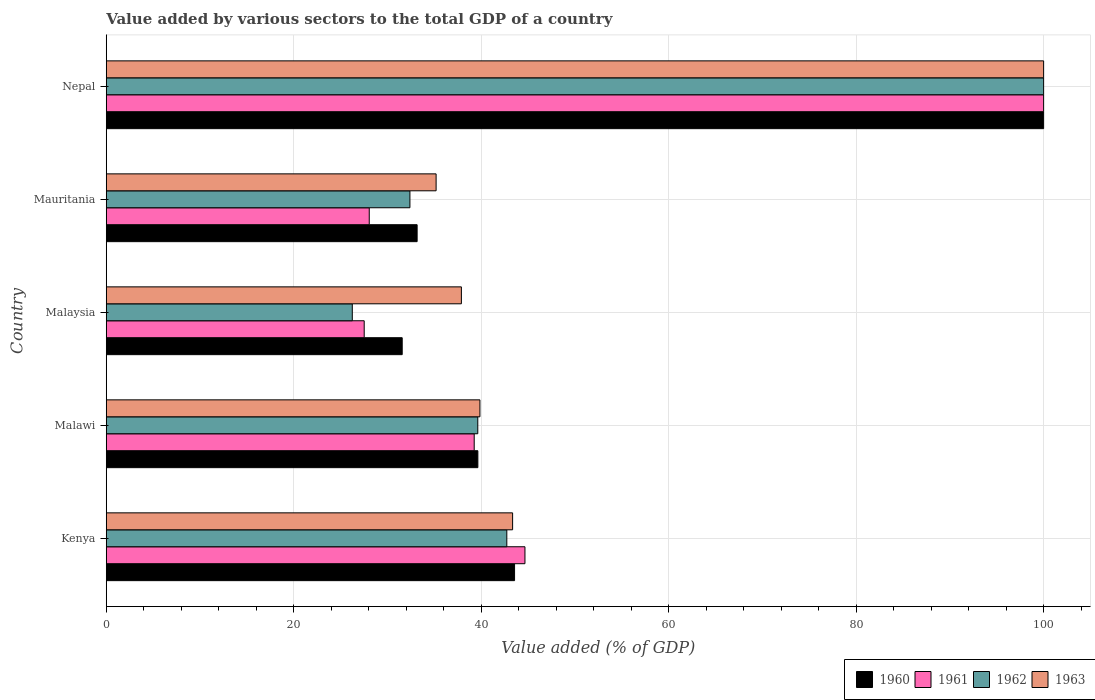How many different coloured bars are there?
Make the answer very short. 4. Are the number of bars per tick equal to the number of legend labels?
Keep it short and to the point. Yes. What is the label of the 2nd group of bars from the top?
Provide a short and direct response. Mauritania. What is the value added by various sectors to the total GDP in 1962 in Malawi?
Keep it short and to the point. 39.64. Across all countries, what is the maximum value added by various sectors to the total GDP in 1960?
Give a very brief answer. 100. Across all countries, what is the minimum value added by various sectors to the total GDP in 1961?
Ensure brevity in your answer.  27.52. In which country was the value added by various sectors to the total GDP in 1962 maximum?
Offer a terse response. Nepal. In which country was the value added by various sectors to the total GDP in 1963 minimum?
Offer a very short reply. Mauritania. What is the total value added by various sectors to the total GDP in 1961 in the graph?
Ensure brevity in your answer.  239.5. What is the difference between the value added by various sectors to the total GDP in 1961 in Kenya and that in Malawi?
Offer a very short reply. 5.41. What is the difference between the value added by various sectors to the total GDP in 1961 in Mauritania and the value added by various sectors to the total GDP in 1960 in Nepal?
Your answer should be compact. -71.94. What is the average value added by various sectors to the total GDP in 1960 per country?
Offer a terse response. 49.59. What is the difference between the value added by various sectors to the total GDP in 1963 and value added by various sectors to the total GDP in 1960 in Mauritania?
Give a very brief answer. 2.02. What is the ratio of the value added by various sectors to the total GDP in 1963 in Kenya to that in Nepal?
Ensure brevity in your answer.  0.43. Is the value added by various sectors to the total GDP in 1963 in Kenya less than that in Nepal?
Your answer should be very brief. Yes. What is the difference between the highest and the second highest value added by various sectors to the total GDP in 1962?
Keep it short and to the point. 57.27. What is the difference between the highest and the lowest value added by various sectors to the total GDP in 1963?
Ensure brevity in your answer.  64.81. In how many countries, is the value added by various sectors to the total GDP in 1961 greater than the average value added by various sectors to the total GDP in 1961 taken over all countries?
Offer a very short reply. 1. Is the sum of the value added by various sectors to the total GDP in 1961 in Malawi and Mauritania greater than the maximum value added by various sectors to the total GDP in 1960 across all countries?
Offer a terse response. No. How many bars are there?
Ensure brevity in your answer.  20. Are all the bars in the graph horizontal?
Ensure brevity in your answer.  Yes. Are the values on the major ticks of X-axis written in scientific E-notation?
Provide a succinct answer. No. Does the graph contain grids?
Provide a short and direct response. Yes. How many legend labels are there?
Make the answer very short. 4. What is the title of the graph?
Your answer should be compact. Value added by various sectors to the total GDP of a country. What is the label or title of the X-axis?
Keep it short and to the point. Value added (% of GDP). What is the label or title of the Y-axis?
Provide a short and direct response. Country. What is the Value added (% of GDP) in 1960 in Kenya?
Keep it short and to the point. 43.56. What is the Value added (% of GDP) in 1961 in Kenya?
Offer a very short reply. 44.67. What is the Value added (% of GDP) in 1962 in Kenya?
Give a very brief answer. 42.73. What is the Value added (% of GDP) in 1963 in Kenya?
Keep it short and to the point. 43.35. What is the Value added (% of GDP) in 1960 in Malawi?
Give a very brief answer. 39.64. What is the Value added (% of GDP) of 1961 in Malawi?
Offer a terse response. 39.25. What is the Value added (% of GDP) in 1962 in Malawi?
Offer a terse response. 39.64. What is the Value added (% of GDP) in 1963 in Malawi?
Give a very brief answer. 39.86. What is the Value added (% of GDP) of 1960 in Malaysia?
Offer a very short reply. 31.57. What is the Value added (% of GDP) in 1961 in Malaysia?
Your answer should be very brief. 27.52. What is the Value added (% of GDP) in 1962 in Malaysia?
Provide a short and direct response. 26.25. What is the Value added (% of GDP) in 1963 in Malaysia?
Your answer should be very brief. 37.89. What is the Value added (% of GDP) in 1960 in Mauritania?
Provide a short and direct response. 33.17. What is the Value added (% of GDP) in 1961 in Mauritania?
Provide a succinct answer. 28.06. What is the Value added (% of GDP) in 1962 in Mauritania?
Keep it short and to the point. 32.4. What is the Value added (% of GDP) in 1963 in Mauritania?
Provide a short and direct response. 35.19. What is the Value added (% of GDP) in 1962 in Nepal?
Offer a terse response. 100. What is the Value added (% of GDP) in 1963 in Nepal?
Your answer should be very brief. 100. Across all countries, what is the maximum Value added (% of GDP) in 1962?
Provide a succinct answer. 100. Across all countries, what is the maximum Value added (% of GDP) in 1963?
Make the answer very short. 100. Across all countries, what is the minimum Value added (% of GDP) in 1960?
Give a very brief answer. 31.57. Across all countries, what is the minimum Value added (% of GDP) of 1961?
Make the answer very short. 27.52. Across all countries, what is the minimum Value added (% of GDP) of 1962?
Offer a very short reply. 26.25. Across all countries, what is the minimum Value added (% of GDP) in 1963?
Keep it short and to the point. 35.19. What is the total Value added (% of GDP) in 1960 in the graph?
Keep it short and to the point. 247.94. What is the total Value added (% of GDP) of 1961 in the graph?
Make the answer very short. 239.5. What is the total Value added (% of GDP) of 1962 in the graph?
Offer a very short reply. 241.01. What is the total Value added (% of GDP) in 1963 in the graph?
Your answer should be compact. 256.29. What is the difference between the Value added (% of GDP) of 1960 in Kenya and that in Malawi?
Your answer should be compact. 3.92. What is the difference between the Value added (% of GDP) in 1961 in Kenya and that in Malawi?
Keep it short and to the point. 5.41. What is the difference between the Value added (% of GDP) of 1962 in Kenya and that in Malawi?
Your response must be concise. 3.1. What is the difference between the Value added (% of GDP) of 1963 in Kenya and that in Malawi?
Your answer should be compact. 3.49. What is the difference between the Value added (% of GDP) of 1960 in Kenya and that in Malaysia?
Provide a short and direct response. 11.99. What is the difference between the Value added (% of GDP) of 1961 in Kenya and that in Malaysia?
Provide a succinct answer. 17.15. What is the difference between the Value added (% of GDP) of 1962 in Kenya and that in Malaysia?
Your answer should be very brief. 16.48. What is the difference between the Value added (% of GDP) of 1963 in Kenya and that in Malaysia?
Offer a very short reply. 5.46. What is the difference between the Value added (% of GDP) of 1960 in Kenya and that in Mauritania?
Keep it short and to the point. 10.39. What is the difference between the Value added (% of GDP) in 1961 in Kenya and that in Mauritania?
Your response must be concise. 16.61. What is the difference between the Value added (% of GDP) of 1962 in Kenya and that in Mauritania?
Provide a succinct answer. 10.34. What is the difference between the Value added (% of GDP) in 1963 in Kenya and that in Mauritania?
Offer a terse response. 8.16. What is the difference between the Value added (% of GDP) of 1960 in Kenya and that in Nepal?
Offer a very short reply. -56.44. What is the difference between the Value added (% of GDP) of 1961 in Kenya and that in Nepal?
Ensure brevity in your answer.  -55.33. What is the difference between the Value added (% of GDP) in 1962 in Kenya and that in Nepal?
Your response must be concise. -57.27. What is the difference between the Value added (% of GDP) of 1963 in Kenya and that in Nepal?
Offer a terse response. -56.65. What is the difference between the Value added (% of GDP) in 1960 in Malawi and that in Malaysia?
Give a very brief answer. 8.07. What is the difference between the Value added (% of GDP) of 1961 in Malawi and that in Malaysia?
Give a very brief answer. 11.73. What is the difference between the Value added (% of GDP) of 1962 in Malawi and that in Malaysia?
Provide a short and direct response. 13.39. What is the difference between the Value added (% of GDP) in 1963 in Malawi and that in Malaysia?
Your answer should be compact. 1.98. What is the difference between the Value added (% of GDP) of 1960 in Malawi and that in Mauritania?
Provide a succinct answer. 6.48. What is the difference between the Value added (% of GDP) in 1961 in Malawi and that in Mauritania?
Provide a short and direct response. 11.2. What is the difference between the Value added (% of GDP) of 1962 in Malawi and that in Mauritania?
Offer a very short reply. 7.24. What is the difference between the Value added (% of GDP) of 1963 in Malawi and that in Mauritania?
Your answer should be compact. 4.67. What is the difference between the Value added (% of GDP) of 1960 in Malawi and that in Nepal?
Provide a short and direct response. -60.36. What is the difference between the Value added (% of GDP) in 1961 in Malawi and that in Nepal?
Provide a succinct answer. -60.75. What is the difference between the Value added (% of GDP) of 1962 in Malawi and that in Nepal?
Make the answer very short. -60.36. What is the difference between the Value added (% of GDP) of 1963 in Malawi and that in Nepal?
Offer a very short reply. -60.14. What is the difference between the Value added (% of GDP) of 1960 in Malaysia and that in Mauritania?
Your answer should be compact. -1.59. What is the difference between the Value added (% of GDP) of 1961 in Malaysia and that in Mauritania?
Your response must be concise. -0.54. What is the difference between the Value added (% of GDP) in 1962 in Malaysia and that in Mauritania?
Provide a short and direct response. -6.15. What is the difference between the Value added (% of GDP) of 1963 in Malaysia and that in Mauritania?
Provide a short and direct response. 2.7. What is the difference between the Value added (% of GDP) in 1960 in Malaysia and that in Nepal?
Give a very brief answer. -68.43. What is the difference between the Value added (% of GDP) of 1961 in Malaysia and that in Nepal?
Make the answer very short. -72.48. What is the difference between the Value added (% of GDP) of 1962 in Malaysia and that in Nepal?
Your answer should be compact. -73.75. What is the difference between the Value added (% of GDP) of 1963 in Malaysia and that in Nepal?
Provide a succinct answer. -62.11. What is the difference between the Value added (% of GDP) of 1960 in Mauritania and that in Nepal?
Give a very brief answer. -66.83. What is the difference between the Value added (% of GDP) of 1961 in Mauritania and that in Nepal?
Provide a short and direct response. -71.94. What is the difference between the Value added (% of GDP) in 1962 in Mauritania and that in Nepal?
Your answer should be very brief. -67.6. What is the difference between the Value added (% of GDP) of 1963 in Mauritania and that in Nepal?
Make the answer very short. -64.81. What is the difference between the Value added (% of GDP) in 1960 in Kenya and the Value added (% of GDP) in 1961 in Malawi?
Keep it short and to the point. 4.31. What is the difference between the Value added (% of GDP) of 1960 in Kenya and the Value added (% of GDP) of 1962 in Malawi?
Give a very brief answer. 3.92. What is the difference between the Value added (% of GDP) of 1960 in Kenya and the Value added (% of GDP) of 1963 in Malawi?
Your answer should be very brief. 3.7. What is the difference between the Value added (% of GDP) of 1961 in Kenya and the Value added (% of GDP) of 1962 in Malawi?
Give a very brief answer. 5.03. What is the difference between the Value added (% of GDP) of 1961 in Kenya and the Value added (% of GDP) of 1963 in Malawi?
Ensure brevity in your answer.  4.8. What is the difference between the Value added (% of GDP) in 1962 in Kenya and the Value added (% of GDP) in 1963 in Malawi?
Your response must be concise. 2.87. What is the difference between the Value added (% of GDP) in 1960 in Kenya and the Value added (% of GDP) in 1961 in Malaysia?
Your answer should be compact. 16.04. What is the difference between the Value added (% of GDP) of 1960 in Kenya and the Value added (% of GDP) of 1962 in Malaysia?
Offer a very short reply. 17.31. What is the difference between the Value added (% of GDP) in 1960 in Kenya and the Value added (% of GDP) in 1963 in Malaysia?
Provide a short and direct response. 5.67. What is the difference between the Value added (% of GDP) of 1961 in Kenya and the Value added (% of GDP) of 1962 in Malaysia?
Give a very brief answer. 18.42. What is the difference between the Value added (% of GDP) in 1961 in Kenya and the Value added (% of GDP) in 1963 in Malaysia?
Your answer should be compact. 6.78. What is the difference between the Value added (% of GDP) of 1962 in Kenya and the Value added (% of GDP) of 1963 in Malaysia?
Provide a short and direct response. 4.84. What is the difference between the Value added (% of GDP) in 1960 in Kenya and the Value added (% of GDP) in 1961 in Mauritania?
Offer a very short reply. 15.5. What is the difference between the Value added (% of GDP) of 1960 in Kenya and the Value added (% of GDP) of 1962 in Mauritania?
Offer a terse response. 11.16. What is the difference between the Value added (% of GDP) in 1960 in Kenya and the Value added (% of GDP) in 1963 in Mauritania?
Your response must be concise. 8.37. What is the difference between the Value added (% of GDP) in 1961 in Kenya and the Value added (% of GDP) in 1962 in Mauritania?
Your answer should be compact. 12.27. What is the difference between the Value added (% of GDP) in 1961 in Kenya and the Value added (% of GDP) in 1963 in Mauritania?
Provide a short and direct response. 9.48. What is the difference between the Value added (% of GDP) in 1962 in Kenya and the Value added (% of GDP) in 1963 in Mauritania?
Your answer should be very brief. 7.54. What is the difference between the Value added (% of GDP) of 1960 in Kenya and the Value added (% of GDP) of 1961 in Nepal?
Ensure brevity in your answer.  -56.44. What is the difference between the Value added (% of GDP) of 1960 in Kenya and the Value added (% of GDP) of 1962 in Nepal?
Provide a short and direct response. -56.44. What is the difference between the Value added (% of GDP) of 1960 in Kenya and the Value added (% of GDP) of 1963 in Nepal?
Your response must be concise. -56.44. What is the difference between the Value added (% of GDP) of 1961 in Kenya and the Value added (% of GDP) of 1962 in Nepal?
Your response must be concise. -55.33. What is the difference between the Value added (% of GDP) of 1961 in Kenya and the Value added (% of GDP) of 1963 in Nepal?
Offer a terse response. -55.33. What is the difference between the Value added (% of GDP) in 1962 in Kenya and the Value added (% of GDP) in 1963 in Nepal?
Your answer should be very brief. -57.27. What is the difference between the Value added (% of GDP) in 1960 in Malawi and the Value added (% of GDP) in 1961 in Malaysia?
Give a very brief answer. 12.13. What is the difference between the Value added (% of GDP) in 1960 in Malawi and the Value added (% of GDP) in 1962 in Malaysia?
Provide a succinct answer. 13.39. What is the difference between the Value added (% of GDP) of 1960 in Malawi and the Value added (% of GDP) of 1963 in Malaysia?
Keep it short and to the point. 1.76. What is the difference between the Value added (% of GDP) in 1961 in Malawi and the Value added (% of GDP) in 1962 in Malaysia?
Make the answer very short. 13. What is the difference between the Value added (% of GDP) in 1961 in Malawi and the Value added (% of GDP) in 1963 in Malaysia?
Keep it short and to the point. 1.37. What is the difference between the Value added (% of GDP) in 1962 in Malawi and the Value added (% of GDP) in 1963 in Malaysia?
Your response must be concise. 1.75. What is the difference between the Value added (% of GDP) in 1960 in Malawi and the Value added (% of GDP) in 1961 in Mauritania?
Make the answer very short. 11.59. What is the difference between the Value added (% of GDP) in 1960 in Malawi and the Value added (% of GDP) in 1962 in Mauritania?
Your answer should be very brief. 7.25. What is the difference between the Value added (% of GDP) of 1960 in Malawi and the Value added (% of GDP) of 1963 in Mauritania?
Your response must be concise. 4.45. What is the difference between the Value added (% of GDP) of 1961 in Malawi and the Value added (% of GDP) of 1962 in Mauritania?
Provide a short and direct response. 6.86. What is the difference between the Value added (% of GDP) of 1961 in Malawi and the Value added (% of GDP) of 1963 in Mauritania?
Make the answer very short. 4.06. What is the difference between the Value added (% of GDP) in 1962 in Malawi and the Value added (% of GDP) in 1963 in Mauritania?
Ensure brevity in your answer.  4.45. What is the difference between the Value added (% of GDP) in 1960 in Malawi and the Value added (% of GDP) in 1961 in Nepal?
Offer a very short reply. -60.36. What is the difference between the Value added (% of GDP) of 1960 in Malawi and the Value added (% of GDP) of 1962 in Nepal?
Provide a succinct answer. -60.36. What is the difference between the Value added (% of GDP) in 1960 in Malawi and the Value added (% of GDP) in 1963 in Nepal?
Provide a short and direct response. -60.36. What is the difference between the Value added (% of GDP) of 1961 in Malawi and the Value added (% of GDP) of 1962 in Nepal?
Make the answer very short. -60.75. What is the difference between the Value added (% of GDP) of 1961 in Malawi and the Value added (% of GDP) of 1963 in Nepal?
Your answer should be very brief. -60.75. What is the difference between the Value added (% of GDP) in 1962 in Malawi and the Value added (% of GDP) in 1963 in Nepal?
Offer a very short reply. -60.36. What is the difference between the Value added (% of GDP) of 1960 in Malaysia and the Value added (% of GDP) of 1961 in Mauritania?
Provide a short and direct response. 3.51. What is the difference between the Value added (% of GDP) of 1960 in Malaysia and the Value added (% of GDP) of 1962 in Mauritania?
Give a very brief answer. -0.82. What is the difference between the Value added (% of GDP) in 1960 in Malaysia and the Value added (% of GDP) in 1963 in Mauritania?
Your response must be concise. -3.62. What is the difference between the Value added (% of GDP) of 1961 in Malaysia and the Value added (% of GDP) of 1962 in Mauritania?
Your answer should be compact. -4.88. What is the difference between the Value added (% of GDP) of 1961 in Malaysia and the Value added (% of GDP) of 1963 in Mauritania?
Your answer should be compact. -7.67. What is the difference between the Value added (% of GDP) in 1962 in Malaysia and the Value added (% of GDP) in 1963 in Mauritania?
Give a very brief answer. -8.94. What is the difference between the Value added (% of GDP) of 1960 in Malaysia and the Value added (% of GDP) of 1961 in Nepal?
Your answer should be compact. -68.43. What is the difference between the Value added (% of GDP) of 1960 in Malaysia and the Value added (% of GDP) of 1962 in Nepal?
Give a very brief answer. -68.43. What is the difference between the Value added (% of GDP) of 1960 in Malaysia and the Value added (% of GDP) of 1963 in Nepal?
Offer a terse response. -68.43. What is the difference between the Value added (% of GDP) of 1961 in Malaysia and the Value added (% of GDP) of 1962 in Nepal?
Give a very brief answer. -72.48. What is the difference between the Value added (% of GDP) in 1961 in Malaysia and the Value added (% of GDP) in 1963 in Nepal?
Make the answer very short. -72.48. What is the difference between the Value added (% of GDP) of 1962 in Malaysia and the Value added (% of GDP) of 1963 in Nepal?
Give a very brief answer. -73.75. What is the difference between the Value added (% of GDP) of 1960 in Mauritania and the Value added (% of GDP) of 1961 in Nepal?
Provide a succinct answer. -66.83. What is the difference between the Value added (% of GDP) of 1960 in Mauritania and the Value added (% of GDP) of 1962 in Nepal?
Your answer should be compact. -66.83. What is the difference between the Value added (% of GDP) in 1960 in Mauritania and the Value added (% of GDP) in 1963 in Nepal?
Ensure brevity in your answer.  -66.83. What is the difference between the Value added (% of GDP) of 1961 in Mauritania and the Value added (% of GDP) of 1962 in Nepal?
Offer a terse response. -71.94. What is the difference between the Value added (% of GDP) of 1961 in Mauritania and the Value added (% of GDP) of 1963 in Nepal?
Keep it short and to the point. -71.94. What is the difference between the Value added (% of GDP) of 1962 in Mauritania and the Value added (% of GDP) of 1963 in Nepal?
Ensure brevity in your answer.  -67.6. What is the average Value added (% of GDP) of 1960 per country?
Make the answer very short. 49.59. What is the average Value added (% of GDP) in 1961 per country?
Keep it short and to the point. 47.9. What is the average Value added (% of GDP) in 1962 per country?
Your answer should be very brief. 48.2. What is the average Value added (% of GDP) in 1963 per country?
Provide a succinct answer. 51.26. What is the difference between the Value added (% of GDP) of 1960 and Value added (% of GDP) of 1961 in Kenya?
Offer a very short reply. -1.11. What is the difference between the Value added (% of GDP) of 1960 and Value added (% of GDP) of 1962 in Kenya?
Make the answer very short. 0.83. What is the difference between the Value added (% of GDP) of 1960 and Value added (% of GDP) of 1963 in Kenya?
Keep it short and to the point. 0.21. What is the difference between the Value added (% of GDP) in 1961 and Value added (% of GDP) in 1962 in Kenya?
Make the answer very short. 1.94. What is the difference between the Value added (% of GDP) in 1961 and Value added (% of GDP) in 1963 in Kenya?
Keep it short and to the point. 1.32. What is the difference between the Value added (% of GDP) in 1962 and Value added (% of GDP) in 1963 in Kenya?
Ensure brevity in your answer.  -0.62. What is the difference between the Value added (% of GDP) of 1960 and Value added (% of GDP) of 1961 in Malawi?
Keep it short and to the point. 0.39. What is the difference between the Value added (% of GDP) in 1960 and Value added (% of GDP) in 1962 in Malawi?
Make the answer very short. 0.01. What is the difference between the Value added (% of GDP) in 1960 and Value added (% of GDP) in 1963 in Malawi?
Provide a short and direct response. -0.22. What is the difference between the Value added (% of GDP) of 1961 and Value added (% of GDP) of 1962 in Malawi?
Your answer should be compact. -0.38. What is the difference between the Value added (% of GDP) in 1961 and Value added (% of GDP) in 1963 in Malawi?
Keep it short and to the point. -0.61. What is the difference between the Value added (% of GDP) of 1962 and Value added (% of GDP) of 1963 in Malawi?
Your answer should be compact. -0.23. What is the difference between the Value added (% of GDP) in 1960 and Value added (% of GDP) in 1961 in Malaysia?
Ensure brevity in your answer.  4.05. What is the difference between the Value added (% of GDP) in 1960 and Value added (% of GDP) in 1962 in Malaysia?
Your answer should be compact. 5.32. What is the difference between the Value added (% of GDP) in 1960 and Value added (% of GDP) in 1963 in Malaysia?
Offer a very short reply. -6.31. What is the difference between the Value added (% of GDP) of 1961 and Value added (% of GDP) of 1962 in Malaysia?
Your response must be concise. 1.27. What is the difference between the Value added (% of GDP) of 1961 and Value added (% of GDP) of 1963 in Malaysia?
Ensure brevity in your answer.  -10.37. What is the difference between the Value added (% of GDP) of 1962 and Value added (% of GDP) of 1963 in Malaysia?
Your answer should be very brief. -11.64. What is the difference between the Value added (% of GDP) in 1960 and Value added (% of GDP) in 1961 in Mauritania?
Provide a short and direct response. 5.11. What is the difference between the Value added (% of GDP) of 1960 and Value added (% of GDP) of 1962 in Mauritania?
Make the answer very short. 0.77. What is the difference between the Value added (% of GDP) of 1960 and Value added (% of GDP) of 1963 in Mauritania?
Ensure brevity in your answer.  -2.02. What is the difference between the Value added (% of GDP) of 1961 and Value added (% of GDP) of 1962 in Mauritania?
Offer a very short reply. -4.34. What is the difference between the Value added (% of GDP) in 1961 and Value added (% of GDP) in 1963 in Mauritania?
Your response must be concise. -7.13. What is the difference between the Value added (% of GDP) of 1962 and Value added (% of GDP) of 1963 in Mauritania?
Your response must be concise. -2.79. What is the difference between the Value added (% of GDP) in 1960 and Value added (% of GDP) in 1962 in Nepal?
Your answer should be compact. 0. What is the difference between the Value added (% of GDP) of 1961 and Value added (% of GDP) of 1963 in Nepal?
Your answer should be compact. 0. What is the ratio of the Value added (% of GDP) of 1960 in Kenya to that in Malawi?
Keep it short and to the point. 1.1. What is the ratio of the Value added (% of GDP) of 1961 in Kenya to that in Malawi?
Keep it short and to the point. 1.14. What is the ratio of the Value added (% of GDP) of 1962 in Kenya to that in Malawi?
Make the answer very short. 1.08. What is the ratio of the Value added (% of GDP) in 1963 in Kenya to that in Malawi?
Provide a succinct answer. 1.09. What is the ratio of the Value added (% of GDP) of 1960 in Kenya to that in Malaysia?
Offer a terse response. 1.38. What is the ratio of the Value added (% of GDP) of 1961 in Kenya to that in Malaysia?
Provide a succinct answer. 1.62. What is the ratio of the Value added (% of GDP) in 1962 in Kenya to that in Malaysia?
Provide a succinct answer. 1.63. What is the ratio of the Value added (% of GDP) in 1963 in Kenya to that in Malaysia?
Your answer should be compact. 1.14. What is the ratio of the Value added (% of GDP) in 1960 in Kenya to that in Mauritania?
Keep it short and to the point. 1.31. What is the ratio of the Value added (% of GDP) of 1961 in Kenya to that in Mauritania?
Provide a succinct answer. 1.59. What is the ratio of the Value added (% of GDP) of 1962 in Kenya to that in Mauritania?
Provide a short and direct response. 1.32. What is the ratio of the Value added (% of GDP) of 1963 in Kenya to that in Mauritania?
Make the answer very short. 1.23. What is the ratio of the Value added (% of GDP) in 1960 in Kenya to that in Nepal?
Give a very brief answer. 0.44. What is the ratio of the Value added (% of GDP) in 1961 in Kenya to that in Nepal?
Provide a succinct answer. 0.45. What is the ratio of the Value added (% of GDP) in 1962 in Kenya to that in Nepal?
Ensure brevity in your answer.  0.43. What is the ratio of the Value added (% of GDP) of 1963 in Kenya to that in Nepal?
Your response must be concise. 0.43. What is the ratio of the Value added (% of GDP) in 1960 in Malawi to that in Malaysia?
Your answer should be very brief. 1.26. What is the ratio of the Value added (% of GDP) in 1961 in Malawi to that in Malaysia?
Offer a terse response. 1.43. What is the ratio of the Value added (% of GDP) in 1962 in Malawi to that in Malaysia?
Your answer should be very brief. 1.51. What is the ratio of the Value added (% of GDP) of 1963 in Malawi to that in Malaysia?
Give a very brief answer. 1.05. What is the ratio of the Value added (% of GDP) in 1960 in Malawi to that in Mauritania?
Offer a very short reply. 1.2. What is the ratio of the Value added (% of GDP) in 1961 in Malawi to that in Mauritania?
Provide a short and direct response. 1.4. What is the ratio of the Value added (% of GDP) of 1962 in Malawi to that in Mauritania?
Give a very brief answer. 1.22. What is the ratio of the Value added (% of GDP) of 1963 in Malawi to that in Mauritania?
Your answer should be very brief. 1.13. What is the ratio of the Value added (% of GDP) of 1960 in Malawi to that in Nepal?
Your answer should be very brief. 0.4. What is the ratio of the Value added (% of GDP) in 1961 in Malawi to that in Nepal?
Your response must be concise. 0.39. What is the ratio of the Value added (% of GDP) of 1962 in Malawi to that in Nepal?
Your response must be concise. 0.4. What is the ratio of the Value added (% of GDP) of 1963 in Malawi to that in Nepal?
Your response must be concise. 0.4. What is the ratio of the Value added (% of GDP) in 1961 in Malaysia to that in Mauritania?
Your response must be concise. 0.98. What is the ratio of the Value added (% of GDP) in 1962 in Malaysia to that in Mauritania?
Make the answer very short. 0.81. What is the ratio of the Value added (% of GDP) of 1963 in Malaysia to that in Mauritania?
Provide a short and direct response. 1.08. What is the ratio of the Value added (% of GDP) of 1960 in Malaysia to that in Nepal?
Give a very brief answer. 0.32. What is the ratio of the Value added (% of GDP) in 1961 in Malaysia to that in Nepal?
Keep it short and to the point. 0.28. What is the ratio of the Value added (% of GDP) in 1962 in Malaysia to that in Nepal?
Offer a terse response. 0.26. What is the ratio of the Value added (% of GDP) in 1963 in Malaysia to that in Nepal?
Provide a succinct answer. 0.38. What is the ratio of the Value added (% of GDP) in 1960 in Mauritania to that in Nepal?
Provide a succinct answer. 0.33. What is the ratio of the Value added (% of GDP) in 1961 in Mauritania to that in Nepal?
Your answer should be compact. 0.28. What is the ratio of the Value added (% of GDP) in 1962 in Mauritania to that in Nepal?
Offer a very short reply. 0.32. What is the ratio of the Value added (% of GDP) of 1963 in Mauritania to that in Nepal?
Your response must be concise. 0.35. What is the difference between the highest and the second highest Value added (% of GDP) of 1960?
Your answer should be compact. 56.44. What is the difference between the highest and the second highest Value added (% of GDP) in 1961?
Provide a succinct answer. 55.33. What is the difference between the highest and the second highest Value added (% of GDP) in 1962?
Your response must be concise. 57.27. What is the difference between the highest and the second highest Value added (% of GDP) in 1963?
Your answer should be very brief. 56.65. What is the difference between the highest and the lowest Value added (% of GDP) of 1960?
Keep it short and to the point. 68.43. What is the difference between the highest and the lowest Value added (% of GDP) of 1961?
Your answer should be compact. 72.48. What is the difference between the highest and the lowest Value added (% of GDP) in 1962?
Your answer should be compact. 73.75. What is the difference between the highest and the lowest Value added (% of GDP) of 1963?
Your answer should be very brief. 64.81. 